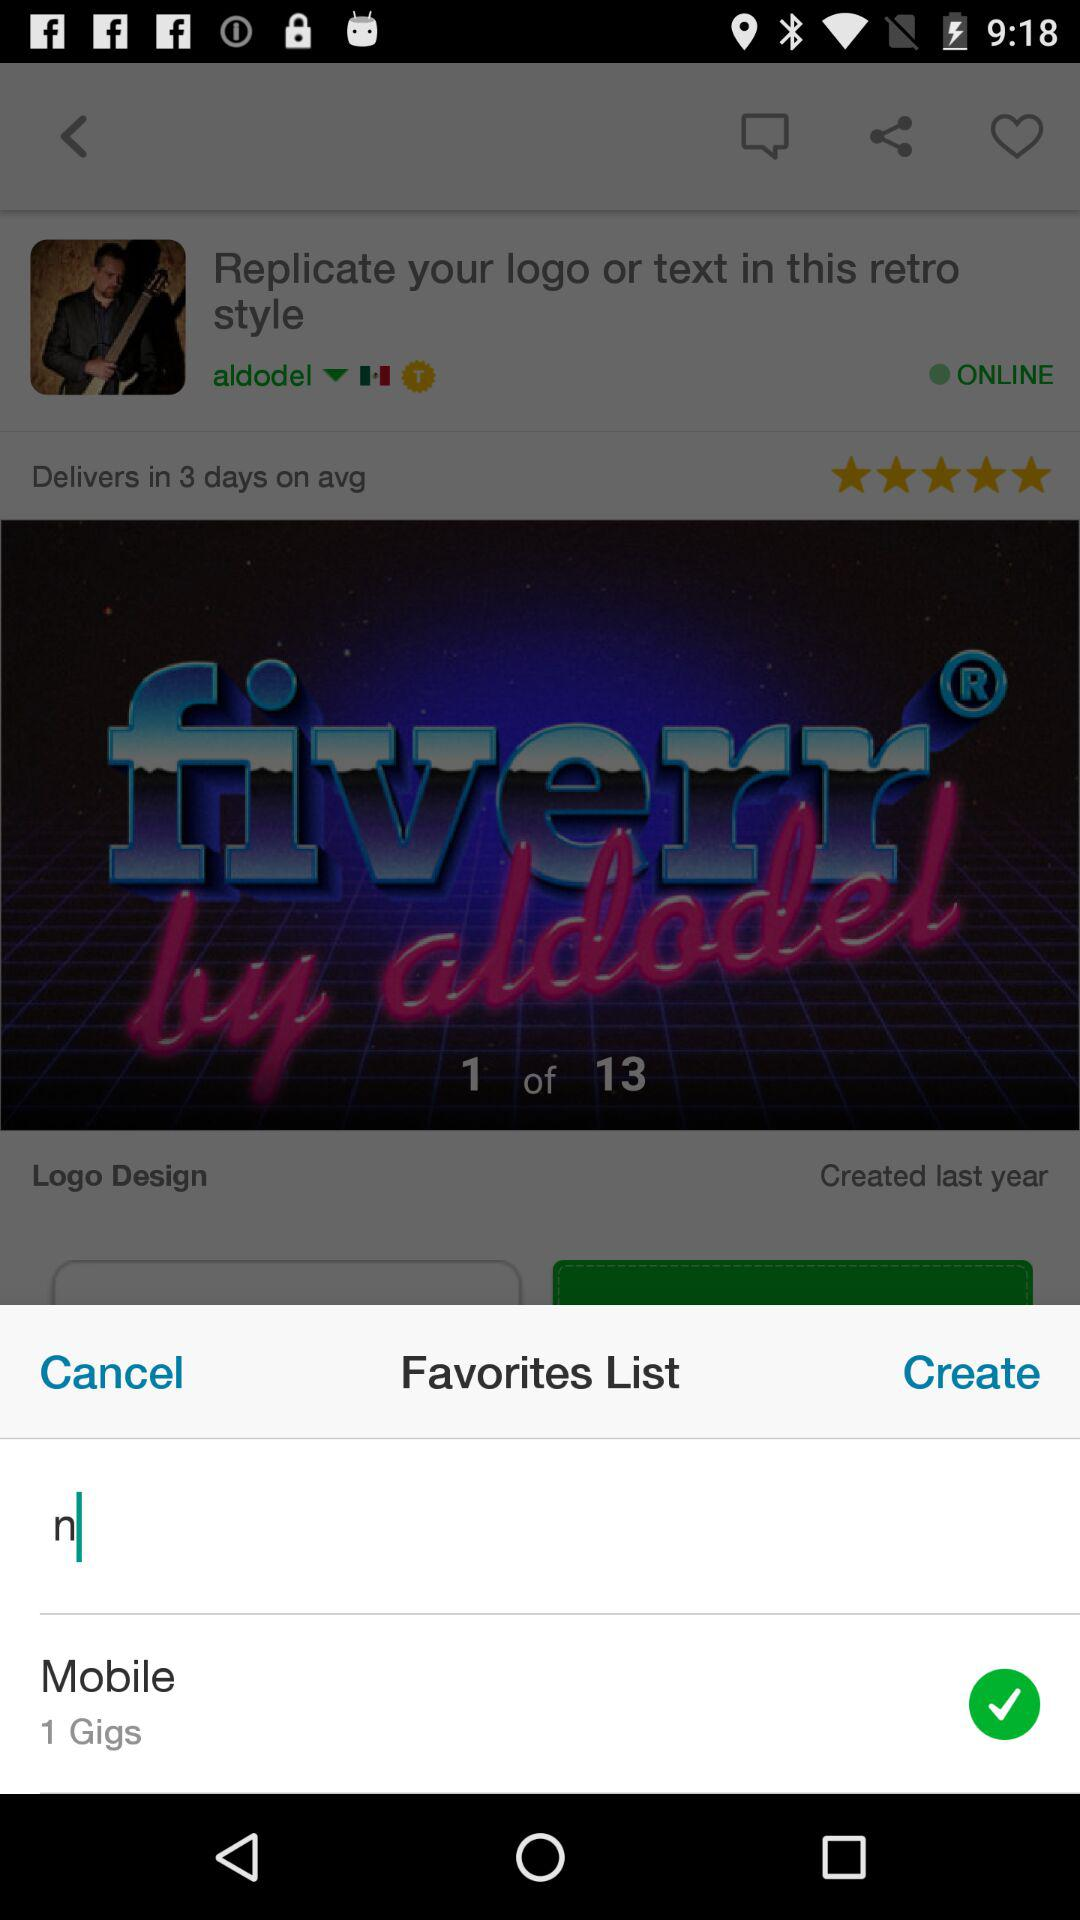How much time does it take for delivery? It takes 3 days for delivery. 